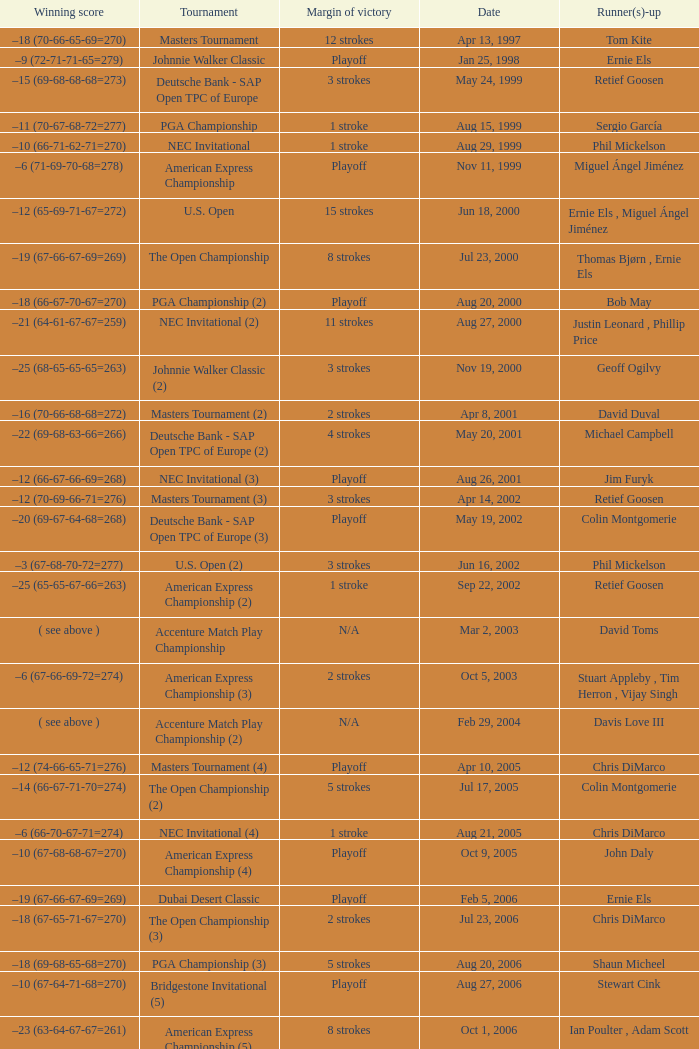Which Tournament has a Margin of victory of 7 strokes Bridgestone Invitational (8). 